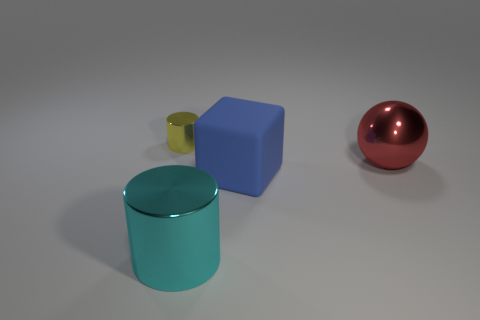How many rubber things are large blue objects or green blocks?
Ensure brevity in your answer.  1. There is a thing that is left of the big thing in front of the cube; what is its material?
Your response must be concise. Metal. What number of objects are tiny yellow cylinders or large shiny things that are in front of the big red metallic object?
Offer a terse response. 2. There is a cyan cylinder that is the same material as the red object; what size is it?
Provide a succinct answer. Large. What number of cyan things are either big metal spheres or tiny metal cylinders?
Your answer should be compact. 0. Is there anything else that is made of the same material as the cube?
Give a very brief answer. No. There is a big object that is in front of the big blue block; is its shape the same as the tiny yellow metal object left of the large matte thing?
Your answer should be very brief. Yes. How many large cyan things are there?
Make the answer very short. 1. What is the shape of the big red thing that is made of the same material as the yellow cylinder?
Your answer should be compact. Sphere. Are there fewer large cubes on the left side of the cyan shiny cylinder than big cyan rubber cylinders?
Keep it short and to the point. No. 